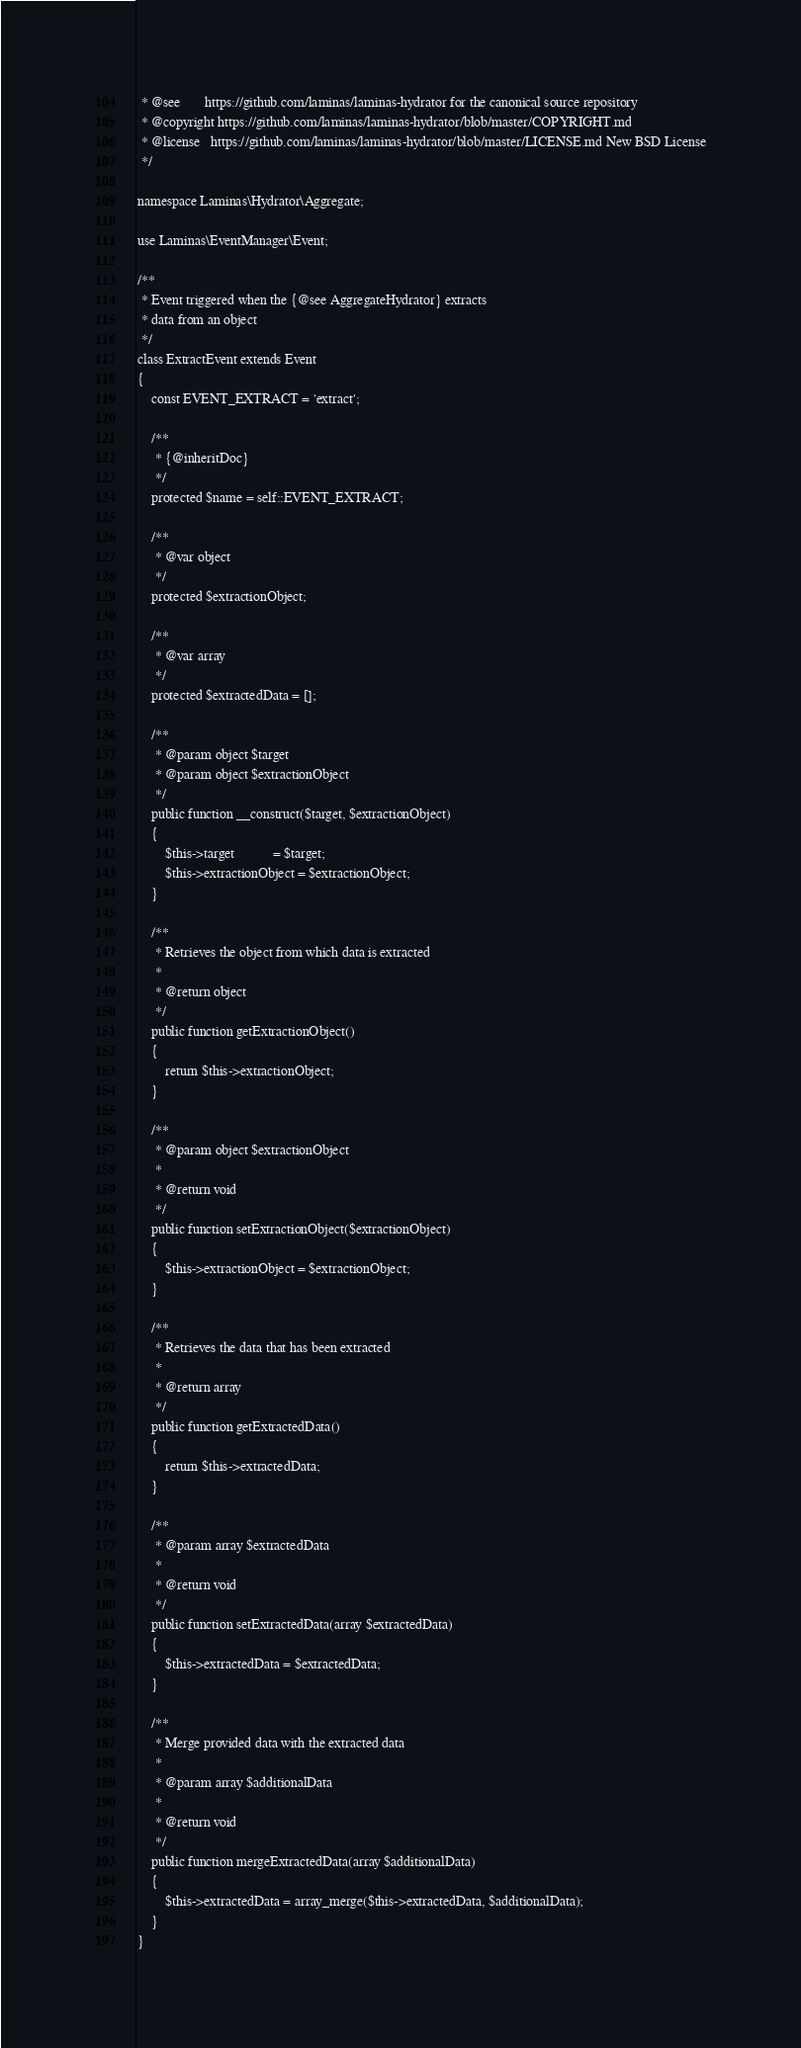<code> <loc_0><loc_0><loc_500><loc_500><_PHP_> * @see       https://github.com/laminas/laminas-hydrator for the canonical source repository
 * @copyright https://github.com/laminas/laminas-hydrator/blob/master/COPYRIGHT.md
 * @license   https://github.com/laminas/laminas-hydrator/blob/master/LICENSE.md New BSD License
 */

namespace Laminas\Hydrator\Aggregate;

use Laminas\EventManager\Event;

/**
 * Event triggered when the {@see AggregateHydrator} extracts
 * data from an object
 */
class ExtractEvent extends Event
{
    const EVENT_EXTRACT = 'extract';

    /**
     * {@inheritDoc}
     */
    protected $name = self::EVENT_EXTRACT;

    /**
     * @var object
     */
    protected $extractionObject;

    /**
     * @var array
     */
    protected $extractedData = [];

    /**
     * @param object $target
     * @param object $extractionObject
     */
    public function __construct($target, $extractionObject)
    {
        $this->target           = $target;
        $this->extractionObject = $extractionObject;
    }

    /**
     * Retrieves the object from which data is extracted
     *
     * @return object
     */
    public function getExtractionObject()
    {
        return $this->extractionObject;
    }

    /**
     * @param object $extractionObject
     *
     * @return void
     */
    public function setExtractionObject($extractionObject)
    {
        $this->extractionObject = $extractionObject;
    }

    /**
     * Retrieves the data that has been extracted
     *
     * @return array
     */
    public function getExtractedData()
    {
        return $this->extractedData;
    }

    /**
     * @param array $extractedData
     *
     * @return void
     */
    public function setExtractedData(array $extractedData)
    {
        $this->extractedData = $extractedData;
    }

    /**
     * Merge provided data with the extracted data
     *
     * @param array $additionalData
     *
     * @return void
     */
    public function mergeExtractedData(array $additionalData)
    {
        $this->extractedData = array_merge($this->extractedData, $additionalData);
    }
}
</code> 